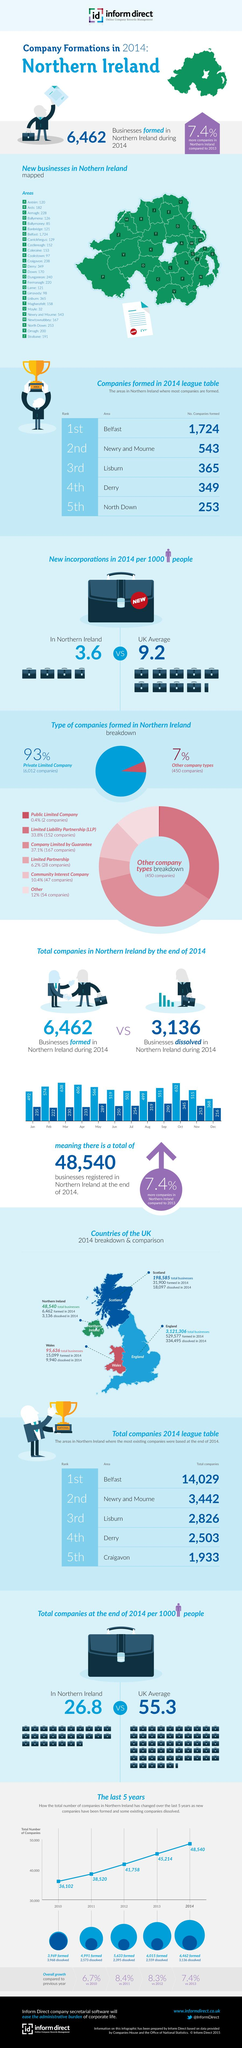Draw attention to some important aspects in this diagram. The majority of companies formed are private limited companies. In 2014, the number of companies formed increased by 7.4% compared to the previous year. In 2014, a total of 3,136 companies were dissolved in Northern Ireland. In 2014, a total of 152 Limited Liability Partnerships (LLPs) were formed in Northern Ireland. In Northern Ireland, there are areas where the number of companies formed in 2014 is above 1000. 